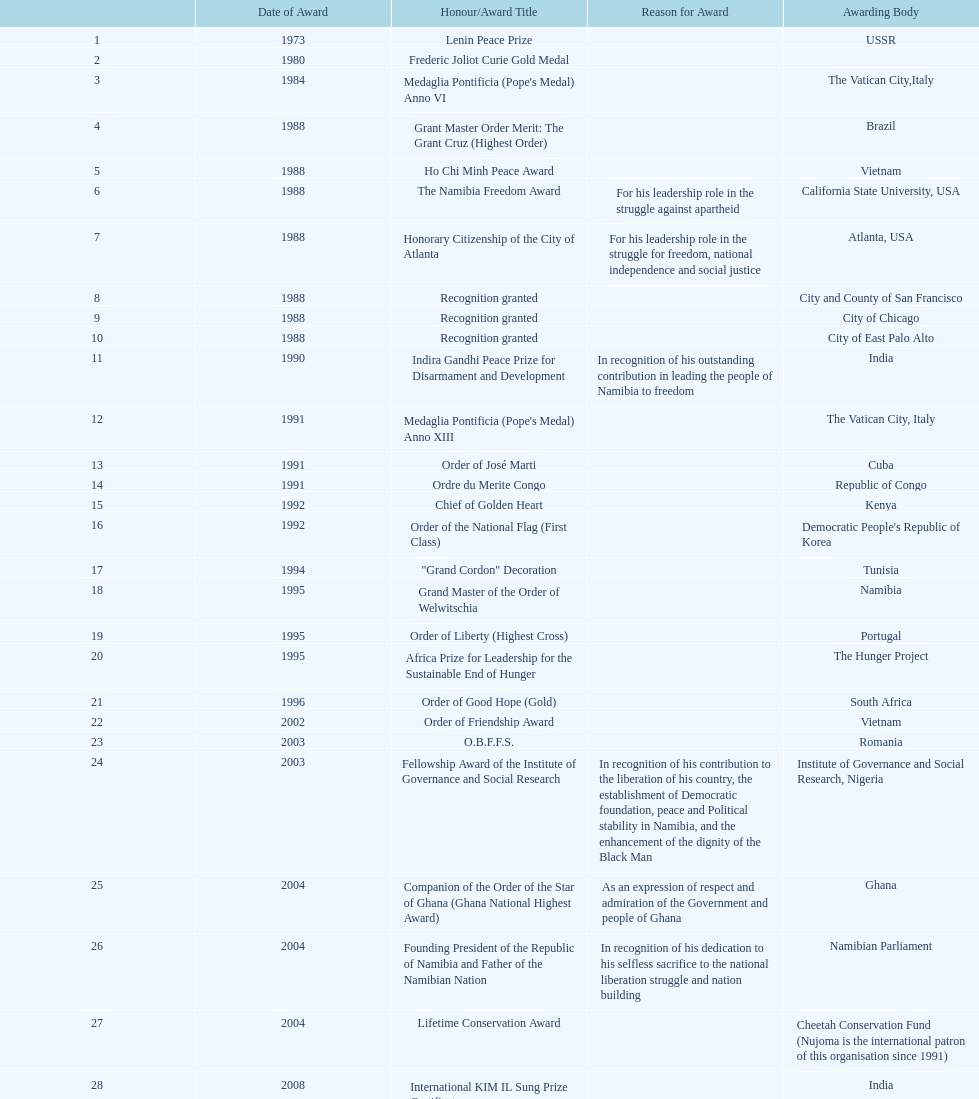Which award did nujoma win last? Sir Seretse Khama SADC Meda. 